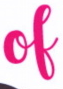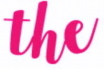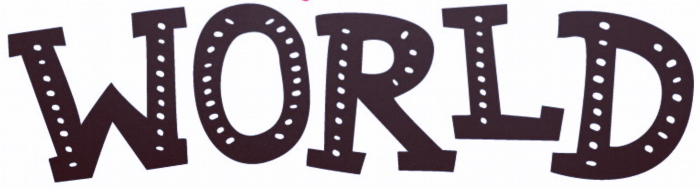What words are shown in these images in order, separated by a semicolon? of; the; WORLD 